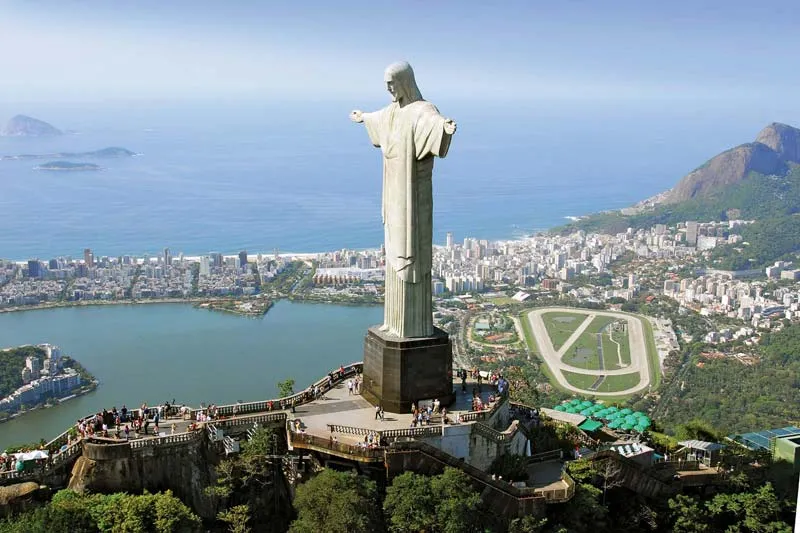How does the surrounding landscape contribute to the reputation of Rio as a beautiful city? The landscape surrounding Christ the Redeemer is a dramatic interplay of natural and urban elements. The lush greenery of the Tijuca Forest, one of the largest urban forests in the world, envelops much of the city, adding a verdant backdrop that enhances Rio's beauty. The hills, including the famous Sugarloaf Mountain, rise steeply from the water’s edge, providing spectacular vistas that are quintessential to Rio’s image. The blend of blue ocean, green landscapes, and vibrant city life observed from this high vantage point encapsulates the dynamic beauty that makes Rio de Janeiro a unique and attractive destination globally. 